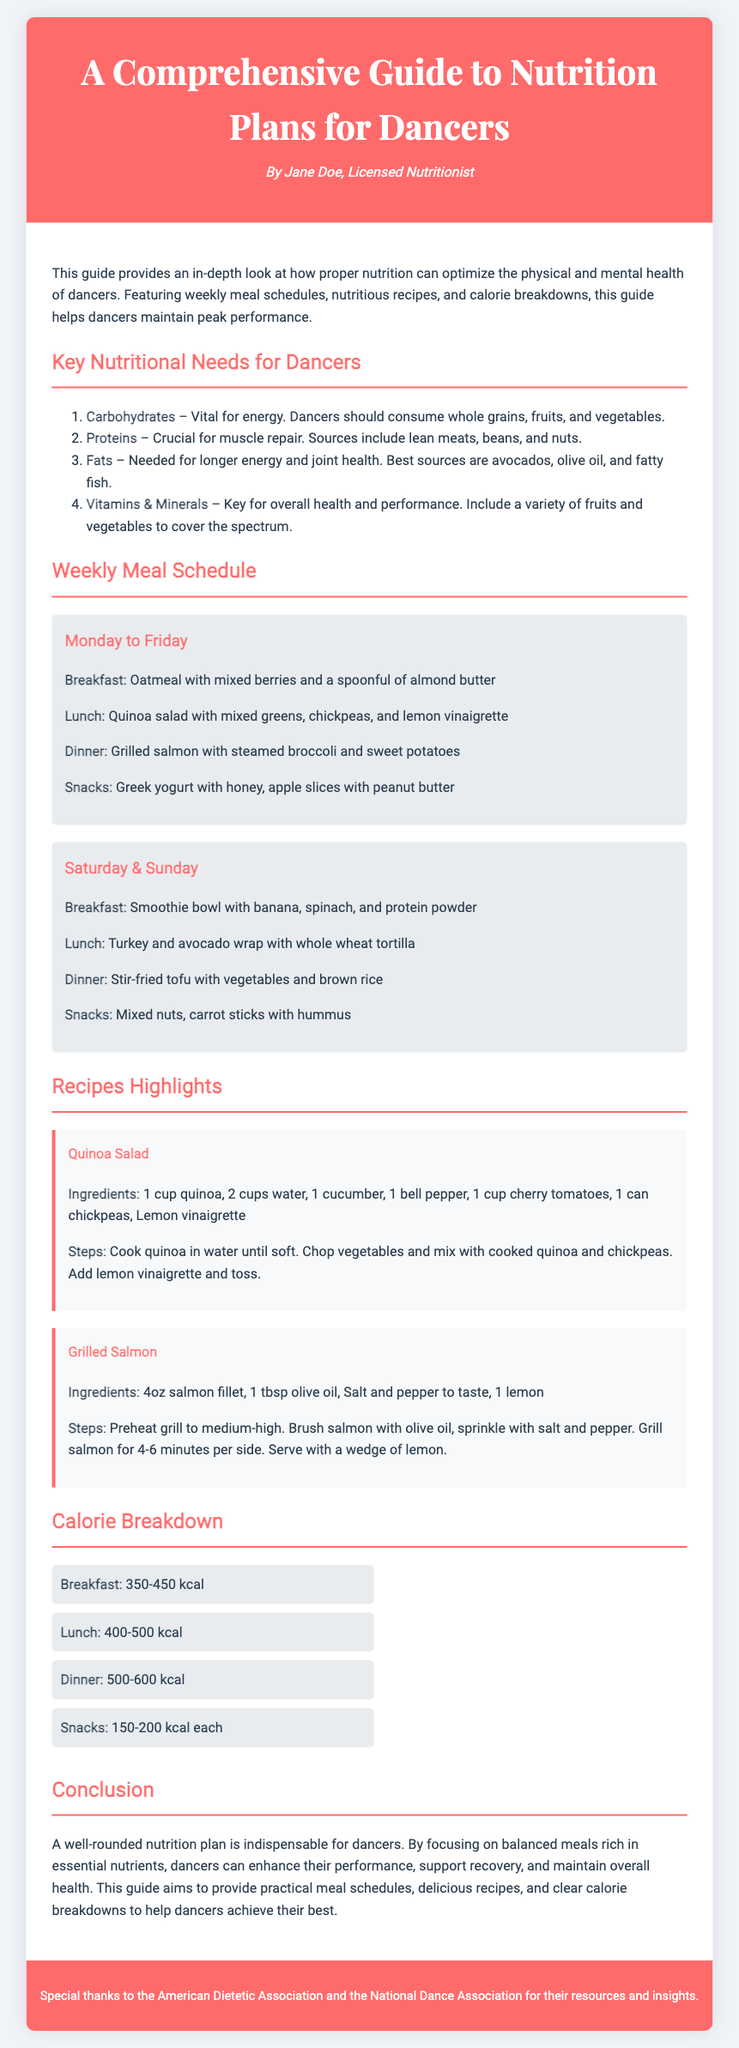what is the title of the diploma? The title of the diploma is stated at the top of the document, which is "A Comprehensive Guide to Nutrition Plans for Dancers."
Answer: A Comprehensive Guide to Nutrition Plans for Dancers who is the author of this guide? The author is mentioned in the header of the document as "Jane Doe, Licensed Nutritionist."
Answer: Jane Doe, Licensed Nutritionist how many key nutritional needs are listed for dancers? The document lists four key nutritional needs for dancers in an ordered list.
Answer: Four what is one of the ingredients for the Quinoa Salad recipe? The ingredients for the Quinoa Salad are explicitly mentioned in the recipe section of the document. One of them is "1 cup quinoa."
Answer: 1 cup quinoa how many calories are suggested for a typical lunch? The calorie breakdown provides a range for lunch, which is specified in the document.
Answer: 400-500 kcal what type of oil is used in the Grilled Salmon recipe? The document clearly states that "1 tbsp olive oil" is used in the recipe for Grilled Salmon.
Answer: Olive oil how are the meals scheduled for the weekends? The meal schedule for Saturday and Sunday is provided separately in the document, detailing specific meals.
Answer: Smoothie bowl, Turkey wrap, Stir-fried tofu what does the calorie breakdown recommend for snacks? The calorie breakdown provides a specific calorie range for snacks in the meal schedule.
Answer: 150-200 kcal each 